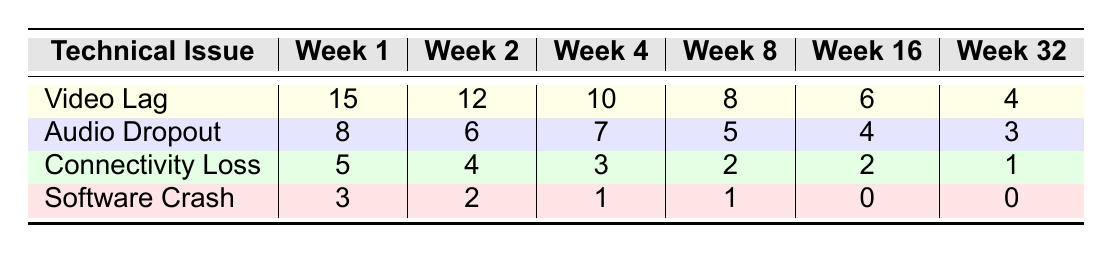What is the highest number of video lag issues reported in a week? The table shows the counts of video lag issues for each week. The highest value is in Week 1 with 15 reported issues.
Answer: 15 In which week was software crash reported the least? The table indicates that software crashes were reported as 0 in both Week 16 and Week 32, making these the weeks with the least reports.
Answer: Week 16 and Week 32 What is the total number of audio dropout issues over the weeks? To find the total audio dropout issues, sum the values: 8 + 6 + 7 + 5 + 4 + 3 = 33.
Answer: 33 During which week did connectivity loss issues decrease compared to the previous week? Reviewing the table, we see that the number of connectivity losses decreased from Week 2 (4 issues) to Week 4 (3 issues).
Answer: Week 2 to Week 4 What is the average number of software crash issues reported across all weeks? The software crash issues reported over the weeks are: 3, 2, 1, 1, 0, and 0. Summing these gives 3 + 2 + 1 + 1 + 0 + 0 = 7. Dividing by 6 weeks yields an average of 7/6 ≈ 1.17.
Answer: Approximately 1.17 Is there a week where no connectivity loss issues were reported? By examining the table, we observe that there were no connectivity loss issues reported in Week 32, where the count is 1.
Answer: No Which technical issue had the highest decrease from Week 1 to Week 32? To find the highest decrease, we observe: Video Lag decreased from 15 to 4 (11), Audio Dropout from 8 to 3 (5), Connectivity Loss from 5 to 1 (4), and Software Crash from 3 to 0 (3). The highest decrease is in Video Lag: 11 issues.
Answer: Video Lag What is the difference in the number of audio dropout issues between Week 1 and Week 4? The audio dropout issues in Week 1 are 8, and in Week 4 are 7. The difference is calculated as 8 - 7 = 1 issue.
Answer: 1 Summarize the trend of video lag issues over the weeks. The table indicates a clear declining trend in video lag issues, from 15 in Week 1 decreasing to 4 in Week 32.
Answer: Decreasing trend Did the total number of technical issues increase or decrease over the weeks? To determine this, we need to sum the technical issues for each week. Weeks show a decreasing trend in technical issues overall: Week 1 (31), Week 2 (26), Week 4 (24), Week 8 (16), Week 16 (12), Week 32 (10). Therefore, total issues decreased.
Answer: Decrease 